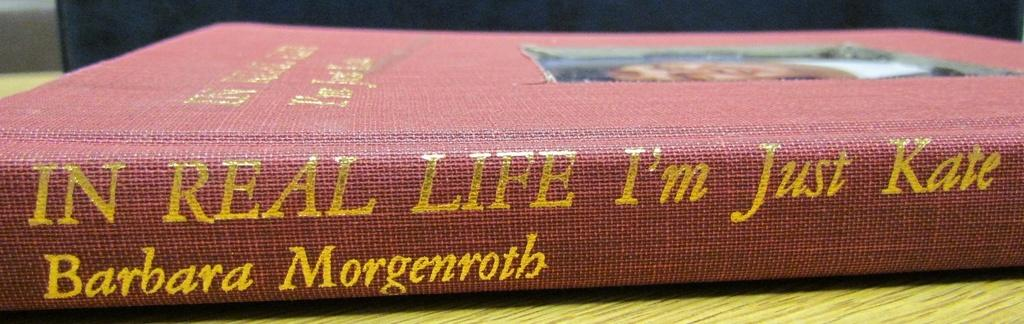<image>
Present a compact description of the photo's key features. In Real Life I am Just Kate was written by Barbara Morgenroth 